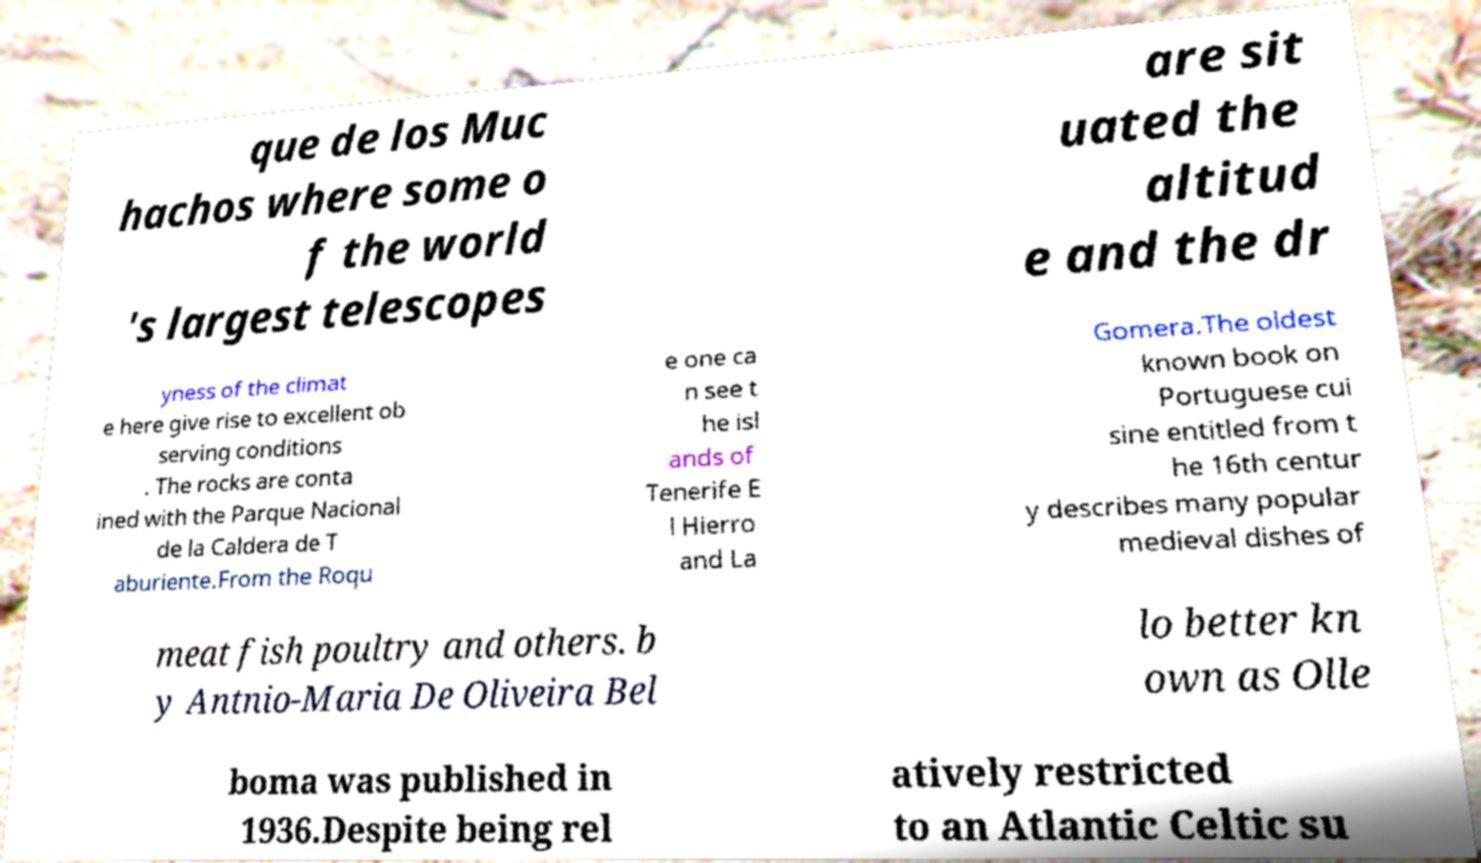Please read and relay the text visible in this image. What does it say? que de los Muc hachos where some o f the world 's largest telescopes are sit uated the altitud e and the dr yness of the climat e here give rise to excellent ob serving conditions . The rocks are conta ined with the Parque Nacional de la Caldera de T aburiente.From the Roqu e one ca n see t he isl ands of Tenerife E l Hierro and La Gomera.The oldest known book on Portuguese cui sine entitled from t he 16th centur y describes many popular medieval dishes of meat fish poultry and others. b y Antnio-Maria De Oliveira Bel lo better kn own as Olle boma was published in 1936.Despite being rel atively restricted to an Atlantic Celtic su 